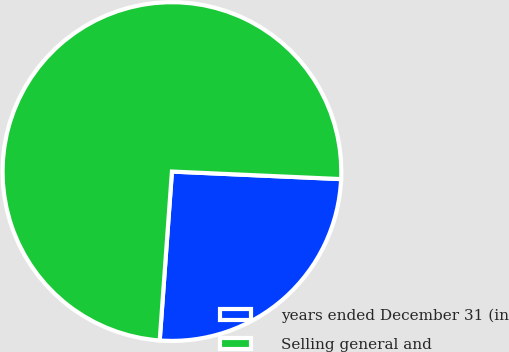Convert chart. <chart><loc_0><loc_0><loc_500><loc_500><pie_chart><fcel>years ended December 31 (in<fcel>Selling general and<nl><fcel>25.44%<fcel>74.56%<nl></chart> 